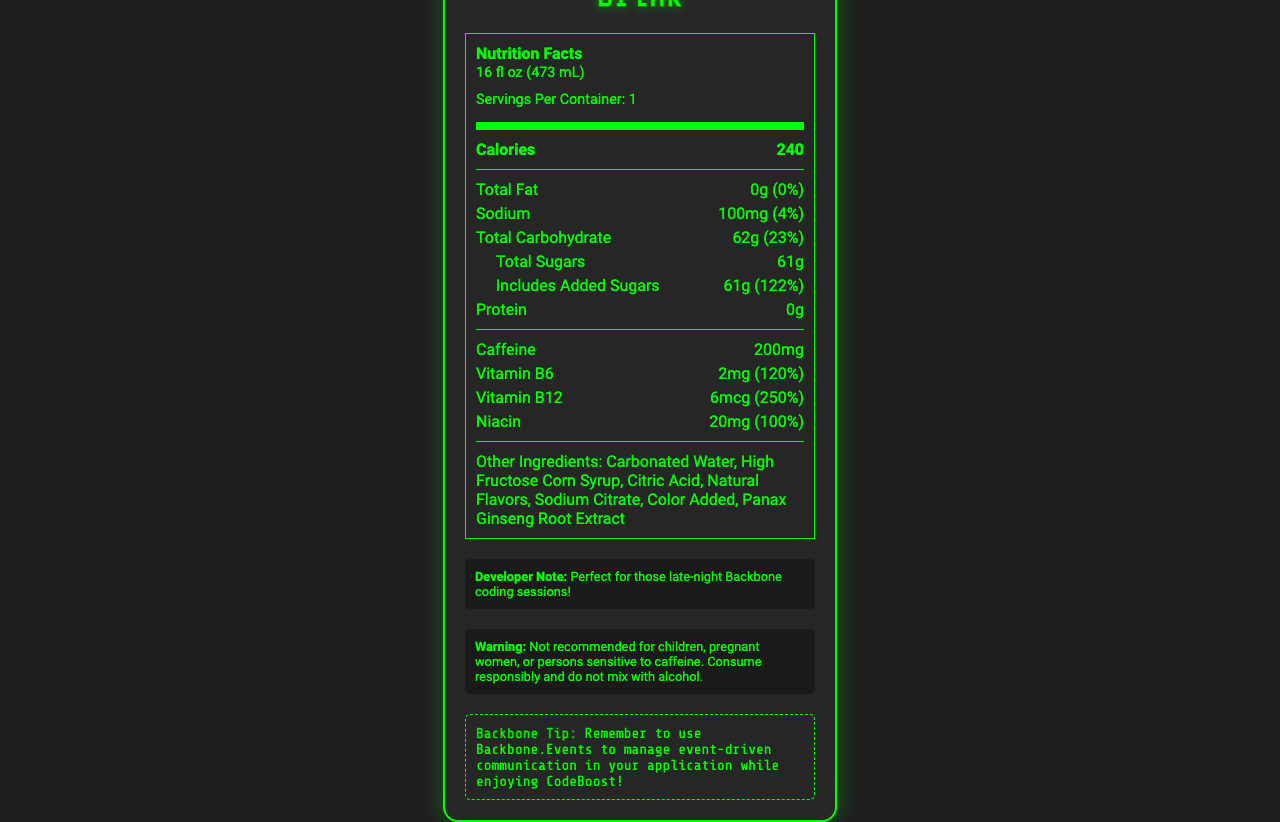what is the serving size? The serving size is listed just below the product name and nutrition facts label header.
Answer: 16 fl oz (473 mL) how many calories are in one serving of CodeBoost Energy Drink? The calories per serving are stated clearly in the bold text within the nutrition facts section.
Answer: 240 what is the sodium content as a percentage of the daily value? The sodium content and its percent daily value are both listed in the respective item under the sodium category.
Answer: 4% how much added sugar is in the drink? Includes Added Sugars is directly stated under the Total Sugars section which mentions 61g.
Answer: 61g how much caffeine does CodeBoost contain per serving? Mentioned in the nutrition label under caffeine, which states it contains 200mg.
Answer: 200mg which vitamins are included in CodeBoost Energy Drink? The listed vitamins and their amounts are Vitamin B6 (2mg), Vitamin B12 (6mcg), and Niacin (20mg).
Answer: Vitamin B6, Vitamin B12, and Niacin what does the document state about children and pregnant women consuming CodeBoost? The warning section clearly states that CodeBoost is not recommended for children and pregnant women.
Answer: Not recommended what is the percent daily value of Vitamin B12 in CodeBoost Energy Drink? A. 100% B. 120% C. 200% D. 250% As stated in the nutrition facts, Vitamin B12 has a daily value of 250%.
Answer: D. 250% which of the following is an ingredient in CodeBoost Energy Drink? A. Citric Acid B. Aspartame C. Sucrose D. Aspartate The other ingredients section lists Citric Acid among other ingredients.
Answer: A. Citric Acid does CodeBoost contain protein? The document lists the protein content as 0g which means there is no protein in the drink.
Answer: No why might a software developer find CodeBoost useful during coding sessions? The document mentions that CodeBoost contains caffeine, taurine, and vitamins that help boost energy, which can be useful for coding sessions.
Answer: It provides energy and contains key vitamins summarize what the Nutrition Facts document for CodeBoost Energy Drink includes. The document comprehensively lists the nutritional content of the energy drink (like calories, sodium, caffeine, vitamins) per serving size, other ingredients, and gives warnings about consumption for certain groups. Additionally, it includes a developer note and a Backbone tip which are particularly targeted at software developers.
Answer: The document provides details about the nutrition facts of CodeBoost Energy Drink, which includes serving size, calories, the amount of fat, sodium, carbohydrates, sugars, caffeine, and several vitamins. It also lists other ingredients present in the drink, a warning statement regarding its consumption, a developer note, and a Backbone coding tip. what is the main carbohydrate component in CodeBoost Energy Drink, and what is its quantity? The total carbohydrate content includes total sugars, with 61g being the sugar component as listed in the document.
Answer: Sugars, 61g what is taurine and in what quantity is it present in the drink? The document lists taurine content (1000mg) but does not explain what taurine specifically is.
Answer: Cannot be determined 